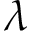Convert formula to latex. <formula><loc_0><loc_0><loc_500><loc_500>\lambda</formula> 